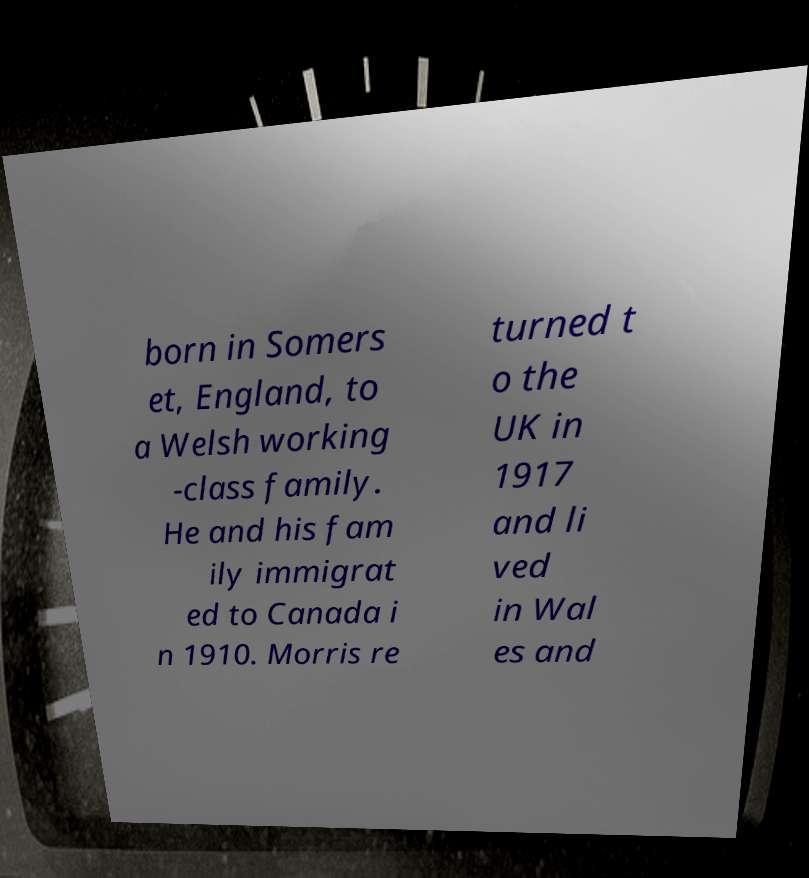Can you accurately transcribe the text from the provided image for me? born in Somers et, England, to a Welsh working -class family. He and his fam ily immigrat ed to Canada i n 1910. Morris re turned t o the UK in 1917 and li ved in Wal es and 